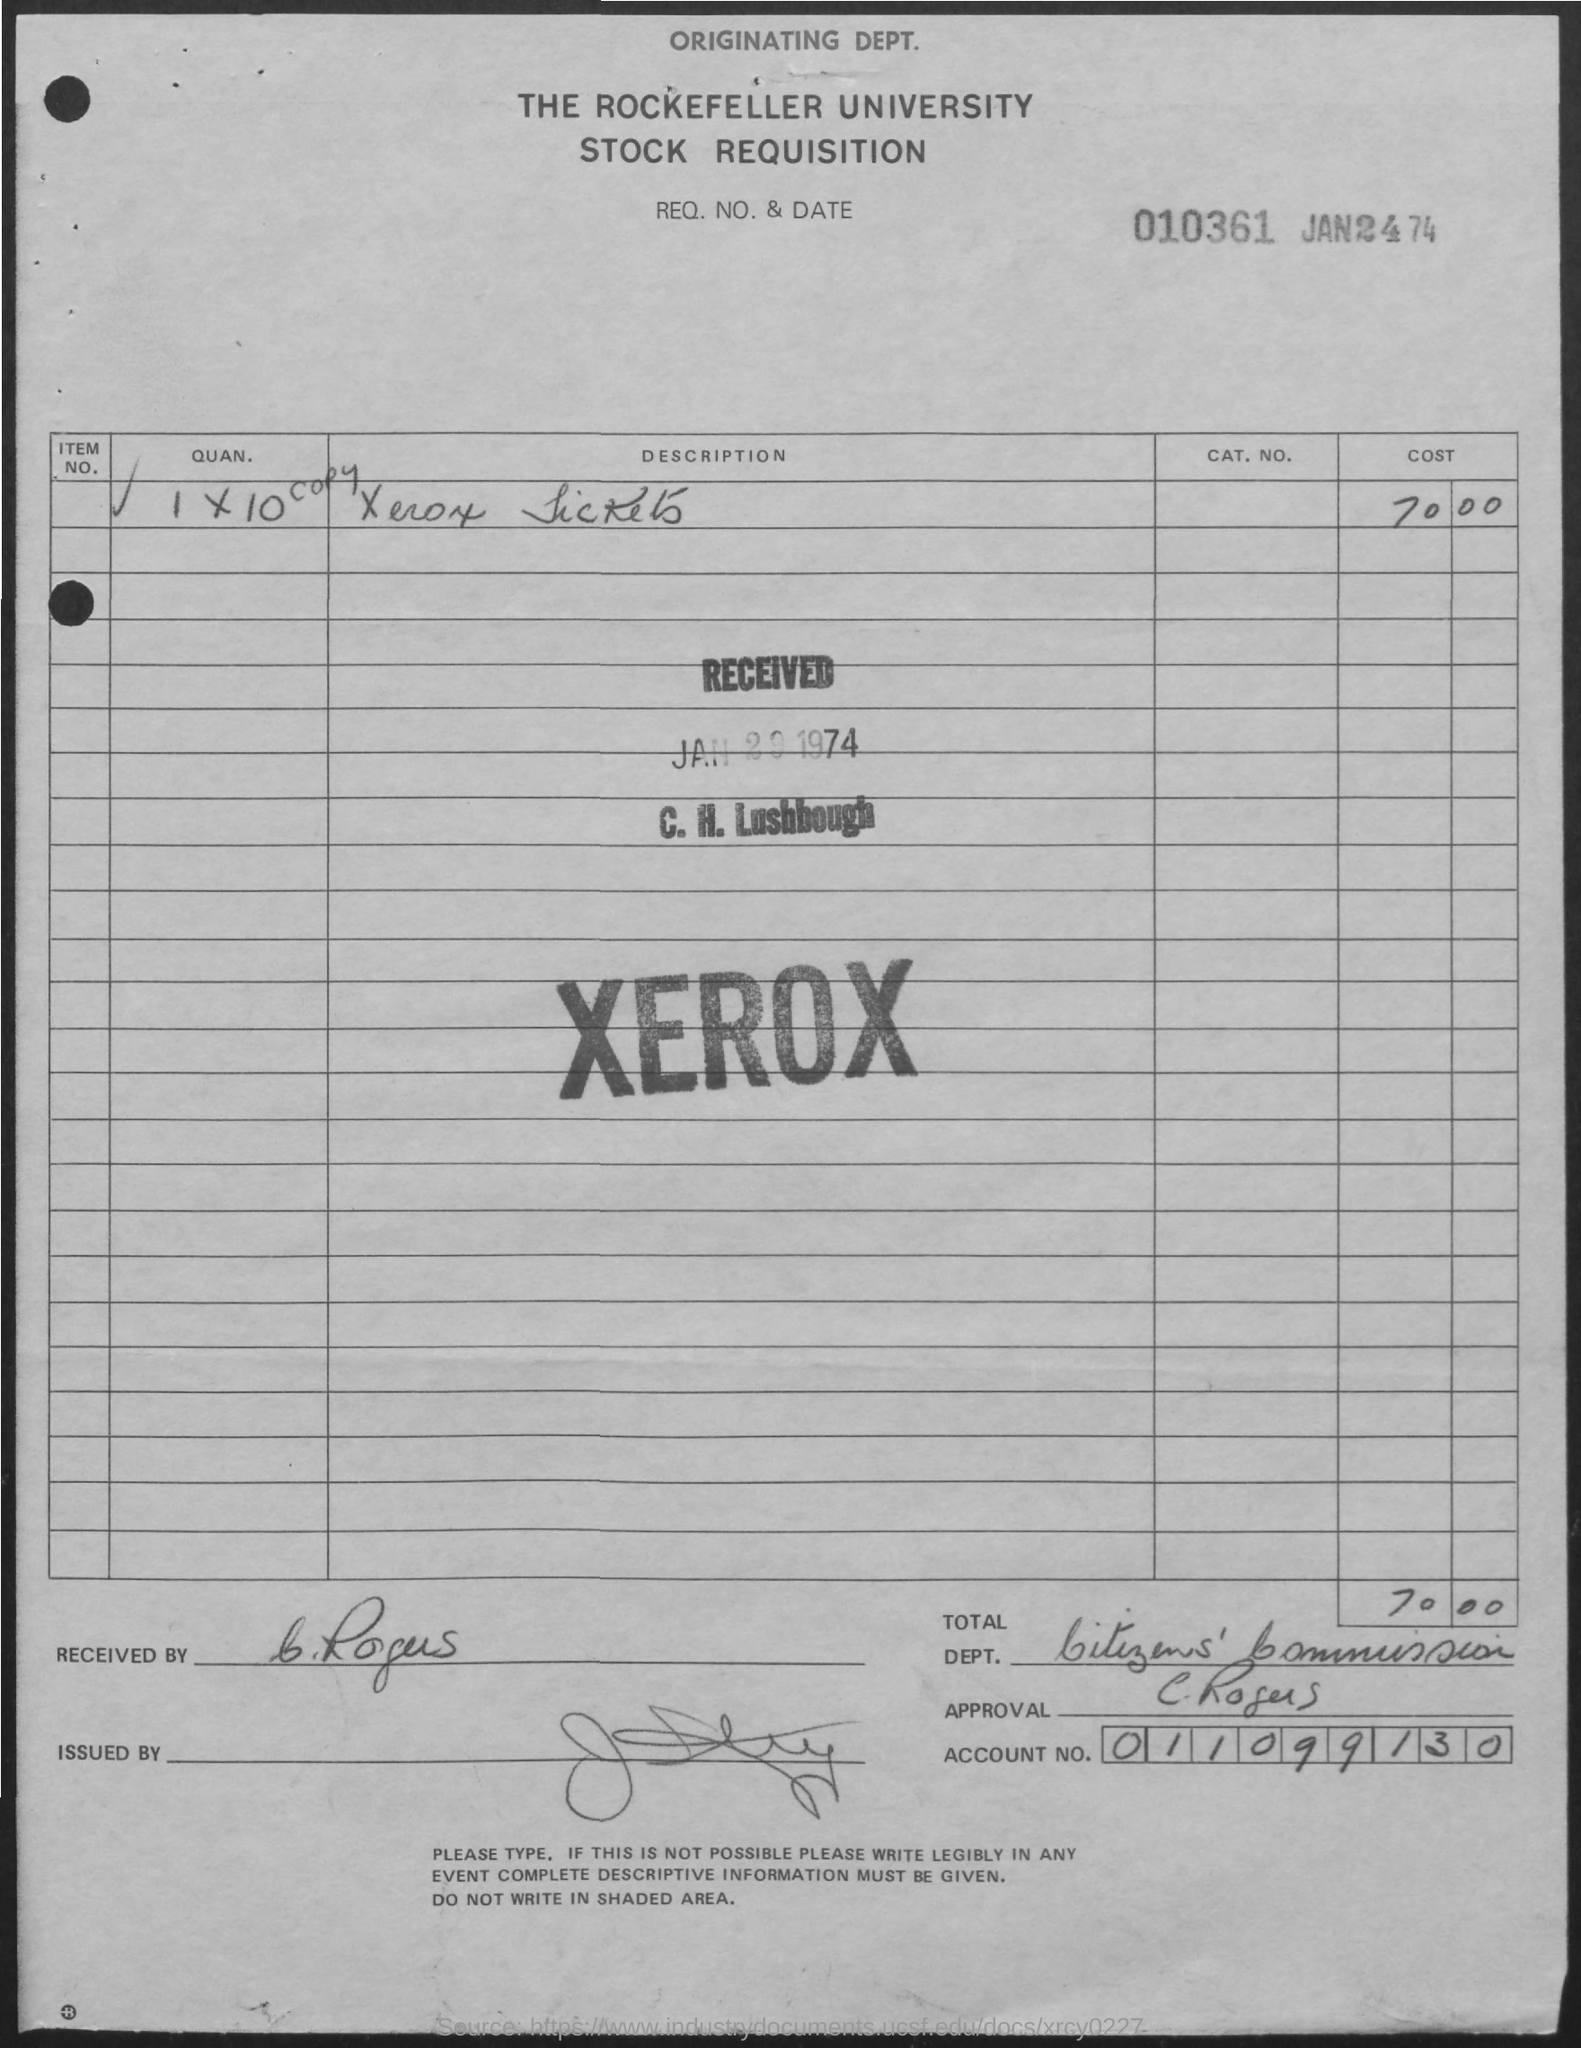Mention a couple of crucial points in this snapshot. The date of the document is January 24, 1974. The request number is 010361... The cost of a Xerox machine is $70.00. 